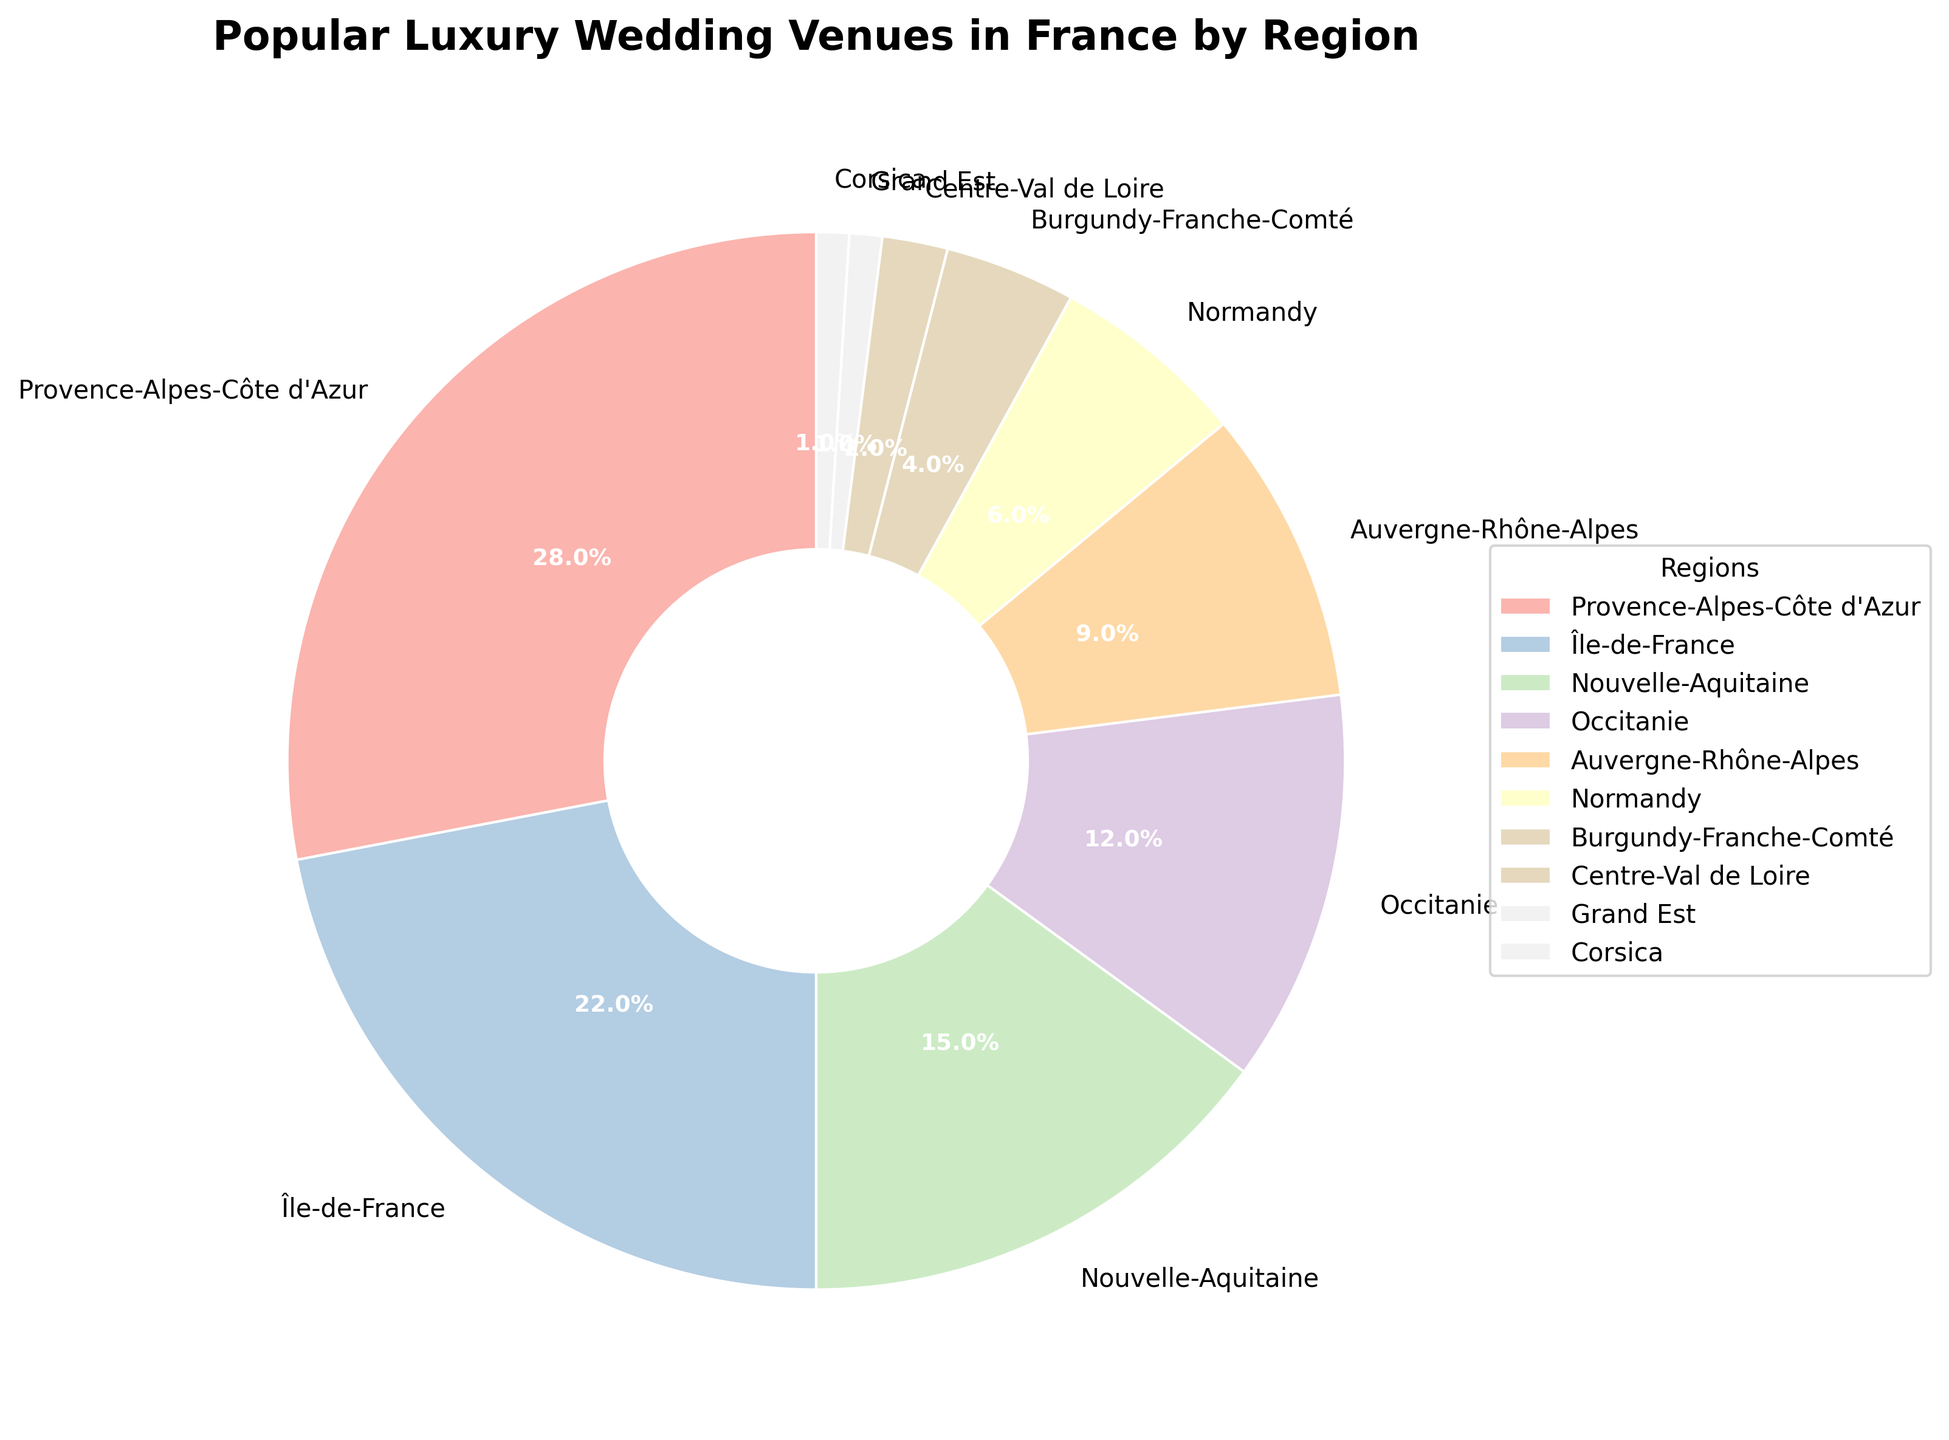what is the most popular region for luxury weddings in France? The largest segment in the pie chart represents Provence-Alpes-Côte d'Azur with 28% of the total.
Answer: Provence-Alpes-Côte d'Azur what is the percentage difference between Île-de-France and Provence-Alpes-Côte d'Azur? Provence-Alpes-Côte d'Azur has 28% while Île-de-France has 22%. The difference is 28% - 22% = 6%.
Answer: 6% which region has the smallest share of luxury weddings? The smallest segments are Grand Est and Corsica, each with 1%.
Answer: Grand Est and Corsica what is the combined percentage of luxury weddings in Île-de-France and Nouvelle-Aquitaine? Île-de-France is 22% and Nouvelle-Aquitaine is 15%. The combined percentage is 22% + 15% = 37%.
Answer: 37% are there more luxury weddings in Normandy or Burgundy-Franche-Comté? Normandy has a 6% share while Burgundy-Franche-Comté has a 4% share, making Normandy larger.
Answer: Normandy what is the total percentage of luxury weddings in regions with less than 10% each? Regions with less than 10% are Auvergne-Rhône-Alpes (9%), Normandy (6%), Burgundy-Franche-Comté (4%), Centre-Val de Loire (2%), Grand Est (1%), and Corsica (1%). The total percentage is 9% + 6% + 4% + 2% + 1% + 1% = 23%.
Answer: 23% how does the percentage of luxury weddings in Occitanie compare to Nouvelle-Aquitaine? Occitanie has 12% while Nouvelle-Aquitaine has 15%. Since 12% is less than 15%, Occitanie has fewer luxury weddings.
Answer: Nouvelle-Aquitaine has more which regions make up more than half of the luxury wedding destinations? Provence-Alpes-Côte d'Azur is 28% and Île-de-France is 22%, together they make 28% + 22% = 50%, exactly half. Adding Nouvelle-Aquitaine with 15%, the combined percentage is 50% + 15% = 65%. Provence-Alpes-Côte d'Azur, Île-de-France, and Nouvelle-Aquitaine make up more than half.
Answer: Provence-Alpes-Côte d'Azur, Île-de-France, and Nouvelle-Aquitaine what is the average percentage share of the three least popular regions? The three least popular regions are Grand Est (1%), Corsica (1%), and Centre-Val de Loire (2%). The average is (1% + 1% + 2%) / 3 = 1.33%.
Answer: 1.33% if you combine the three most popular regions, what percentage do they represent in total? The three most popular regions are Provence-Alpes-Côte d'Azur (28%), Île-de-France (22%), and Nouvelle-Aquitaine (15%). The total percentage is 28% + 22% + 15% = 65%.
Answer: 65% 